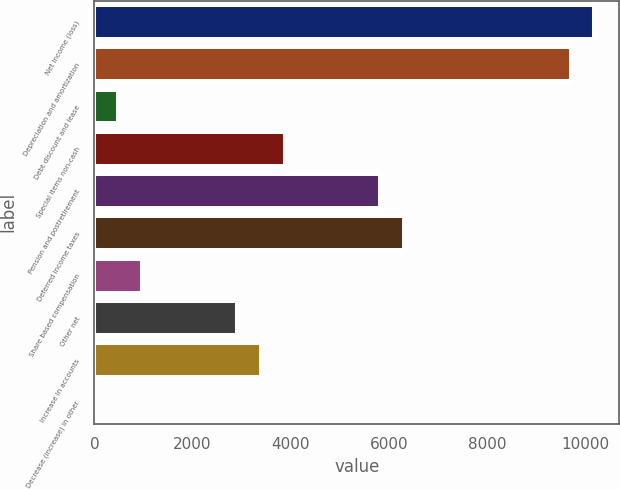Convert chart to OTSL. <chart><loc_0><loc_0><loc_500><loc_500><bar_chart><fcel>Net income (loss)<fcel>Depreciation and amortization<fcel>Debt discount and lease<fcel>Special items non-cash<fcel>Pension and postretirement<fcel>Deferred income taxes<fcel>Share based compensation<fcel>Other net<fcel>Increase in accounts<fcel>Decrease (increase) in other<nl><fcel>10181.7<fcel>9697<fcel>487.7<fcel>3880.6<fcel>5819.4<fcel>6304.1<fcel>972.4<fcel>2911.2<fcel>3395.9<fcel>3<nl></chart> 